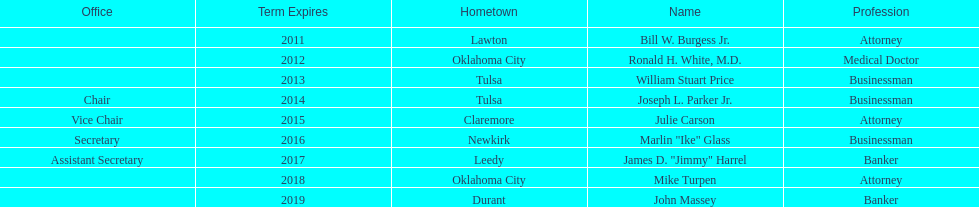Which state regent's term will last the longest? John Massey. 